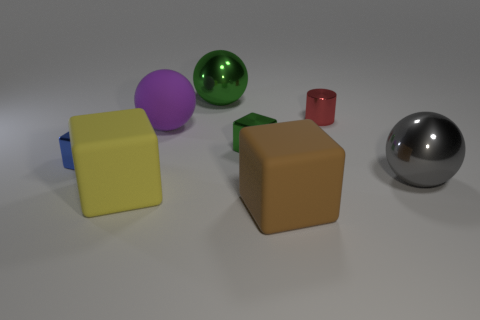Subtract all gray balls. How many balls are left? 2 Subtract 3 blocks. How many blocks are left? 1 Subtract all blue blocks. How many blocks are left? 3 Add 1 red metal cubes. How many objects exist? 9 Subtract all cylinders. How many objects are left? 7 Subtract all blue blocks. Subtract all brown balls. How many blocks are left? 3 Subtract all brown cylinders. How many brown balls are left? 0 Subtract all large purple matte objects. Subtract all tiny blue metallic cubes. How many objects are left? 6 Add 3 tiny green objects. How many tiny green objects are left? 4 Add 4 blue cubes. How many blue cubes exist? 5 